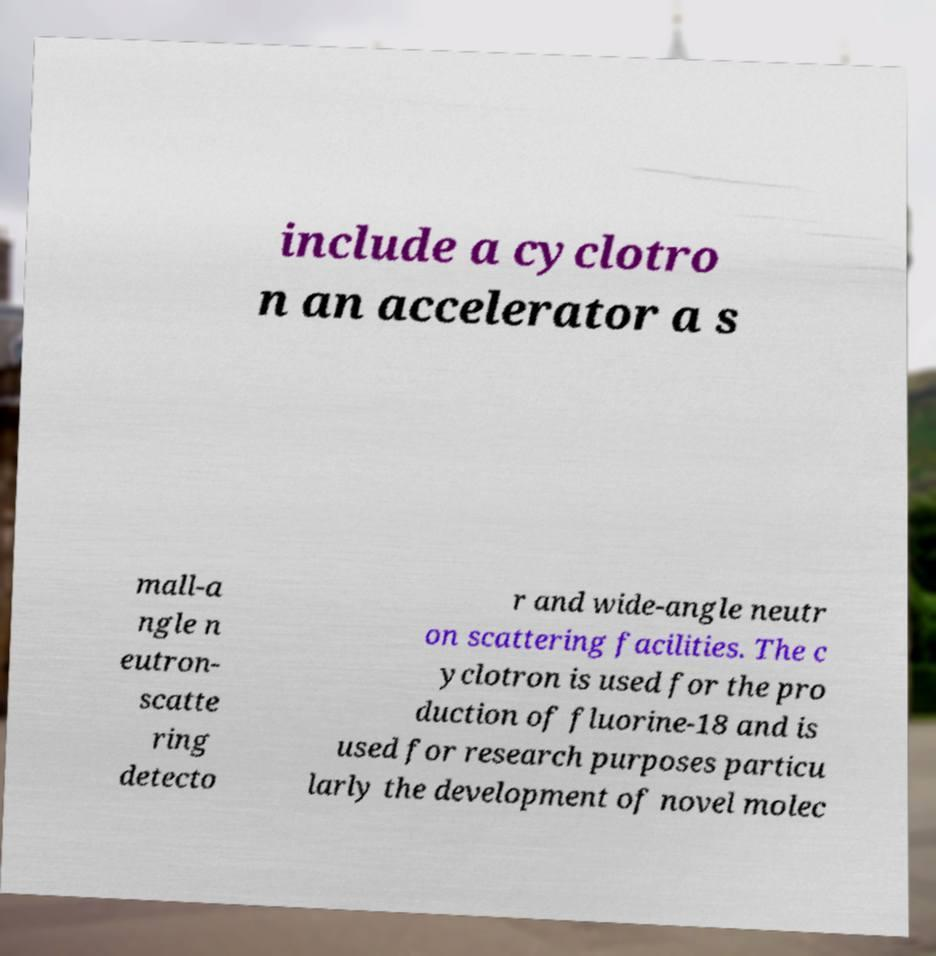Please read and relay the text visible in this image. What does it say? include a cyclotro n an accelerator a s mall-a ngle n eutron- scatte ring detecto r and wide-angle neutr on scattering facilities. The c yclotron is used for the pro duction of fluorine-18 and is used for research purposes particu larly the development of novel molec 